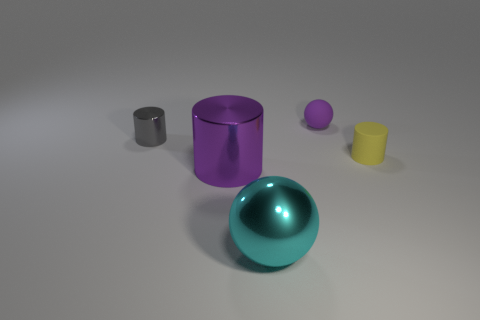Subtract all big cylinders. How many cylinders are left? 2 Subtract all cyan spheres. How many spheres are left? 1 Subtract 1 balls. How many balls are left? 1 Subtract all spheres. How many objects are left? 3 Subtract all purple cylinders. Subtract all brown balls. How many cylinders are left? 2 Subtract all green cylinders. How many red balls are left? 0 Subtract all cyan shiny cylinders. Subtract all purple matte objects. How many objects are left? 4 Add 2 yellow cylinders. How many yellow cylinders are left? 3 Add 1 small gray cylinders. How many small gray cylinders exist? 2 Add 3 small gray objects. How many objects exist? 8 